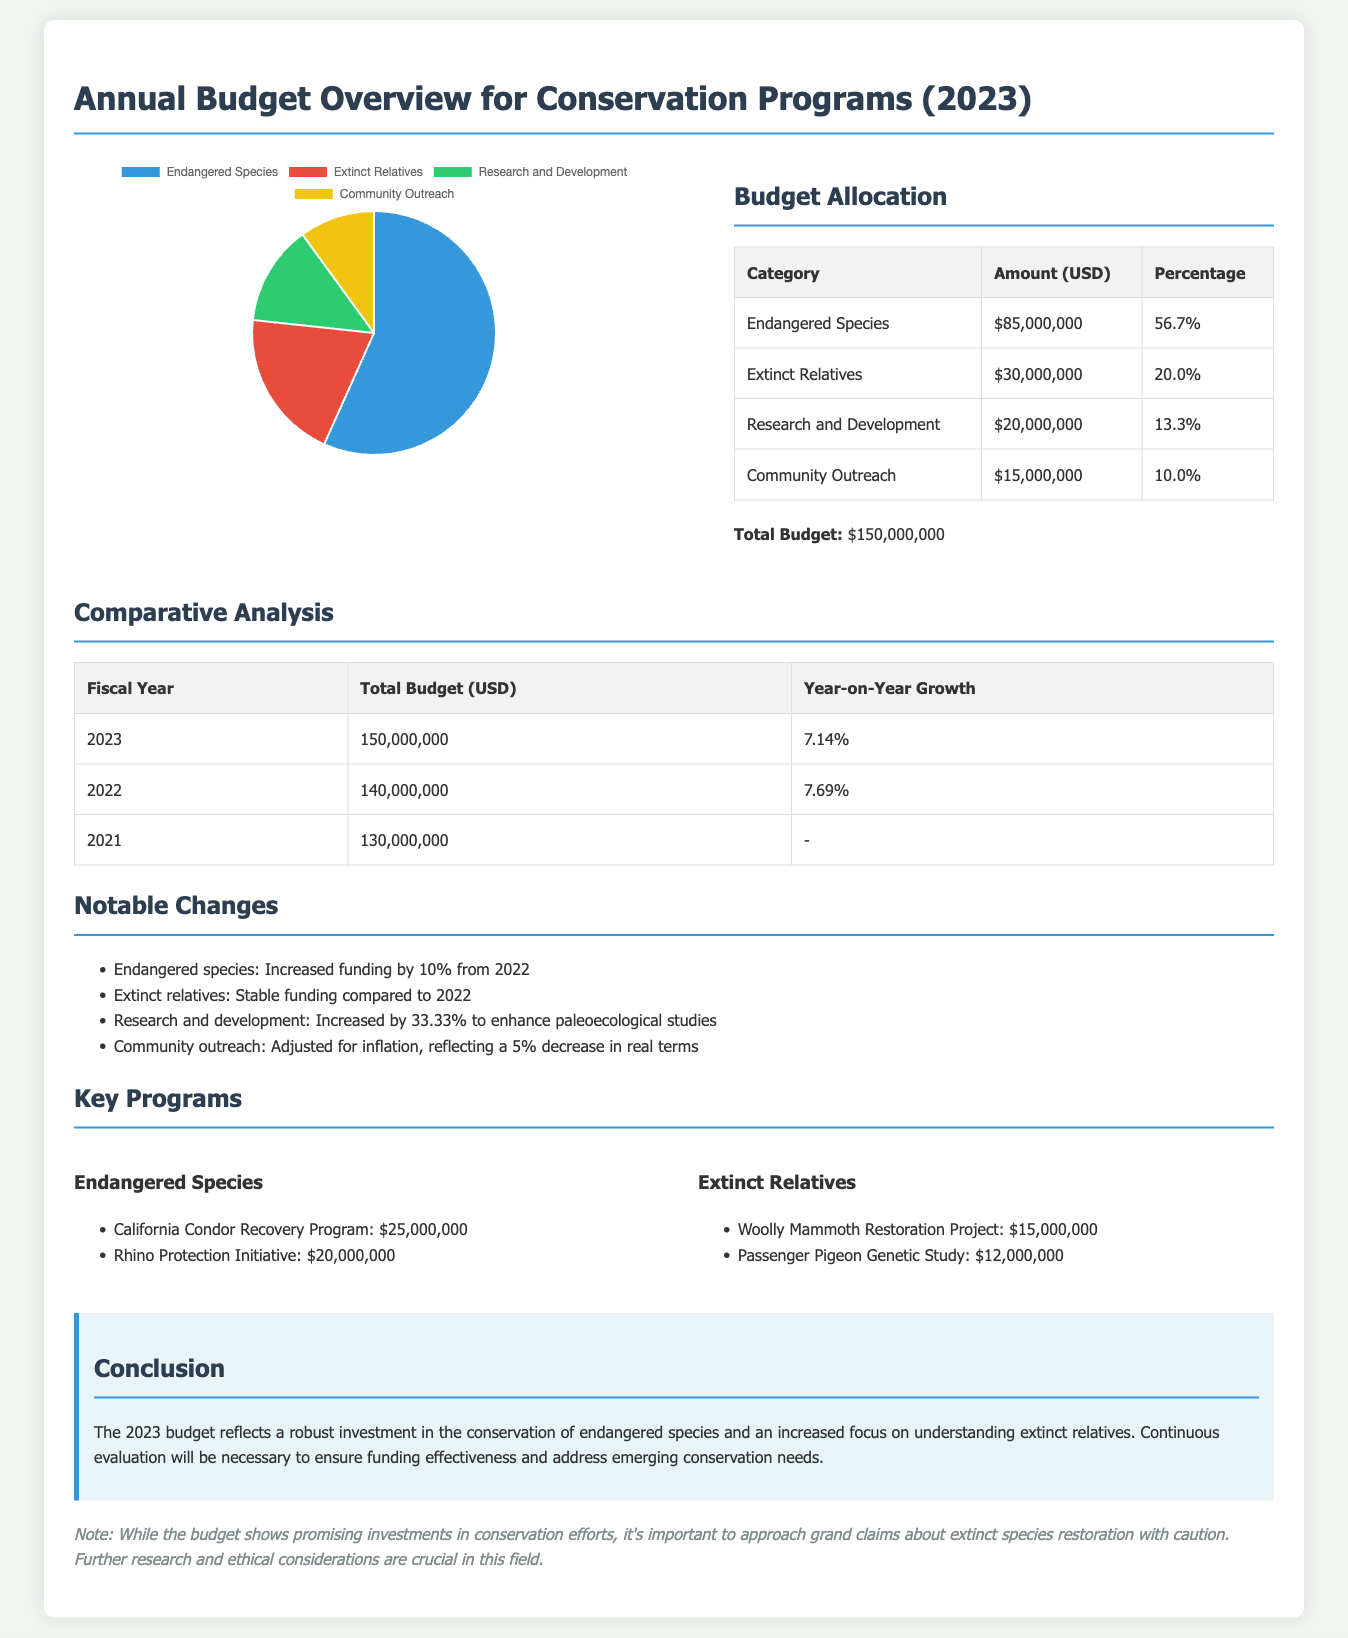What is the total budget for 2023? The total budget is stated clearly at the end of the budget details section, which is $150,000,000.
Answer: $150,000,000 What percentage of the budget is allocated to endangered species? The budget allocation table shows the percentage allocated to endangered species as 56.7%.
Answer: 56.7% What was the year-on-year growth from 2022 to 2023? The comparative analysis section highlights the year-on-year growth as 7.14% for the fiscal year 2023.
Answer: 7.14% How much funding is allocated to the Woolly Mammoth Restoration Project? The key programs section lists funding for the Woolly Mammoth Restoration Project as $15,000,000.
Answer: $15,000,000 What change occurred in community outreach funding from 2022 to 2023? The notable changes section indicates that community outreach funding reflects a 5% decrease in real terms due to inflation adjustments.
Answer: 5% decrease What program received the highest funding under endangered species? The key programs section reveals that the California Condor Recovery Program received the highest funding of $25,000,000 under endangered species.
Answer: $25,000,000 What was the funding increase percentage for research and development? The notable changes section states that research and development funding increased by 33.33% to enhance paleoecological studies.
Answer: 33.33% What is the budget allocation for extinct relatives? The budget allocation table specifies that the amount allocated for extinct relatives is $30,000,000.
Answer: $30,000,000 What was the total budget for 2022? The comparative analysis table shows that the total budget for the fiscal year 2022 is $140,000,000.
Answer: $140,000,000 